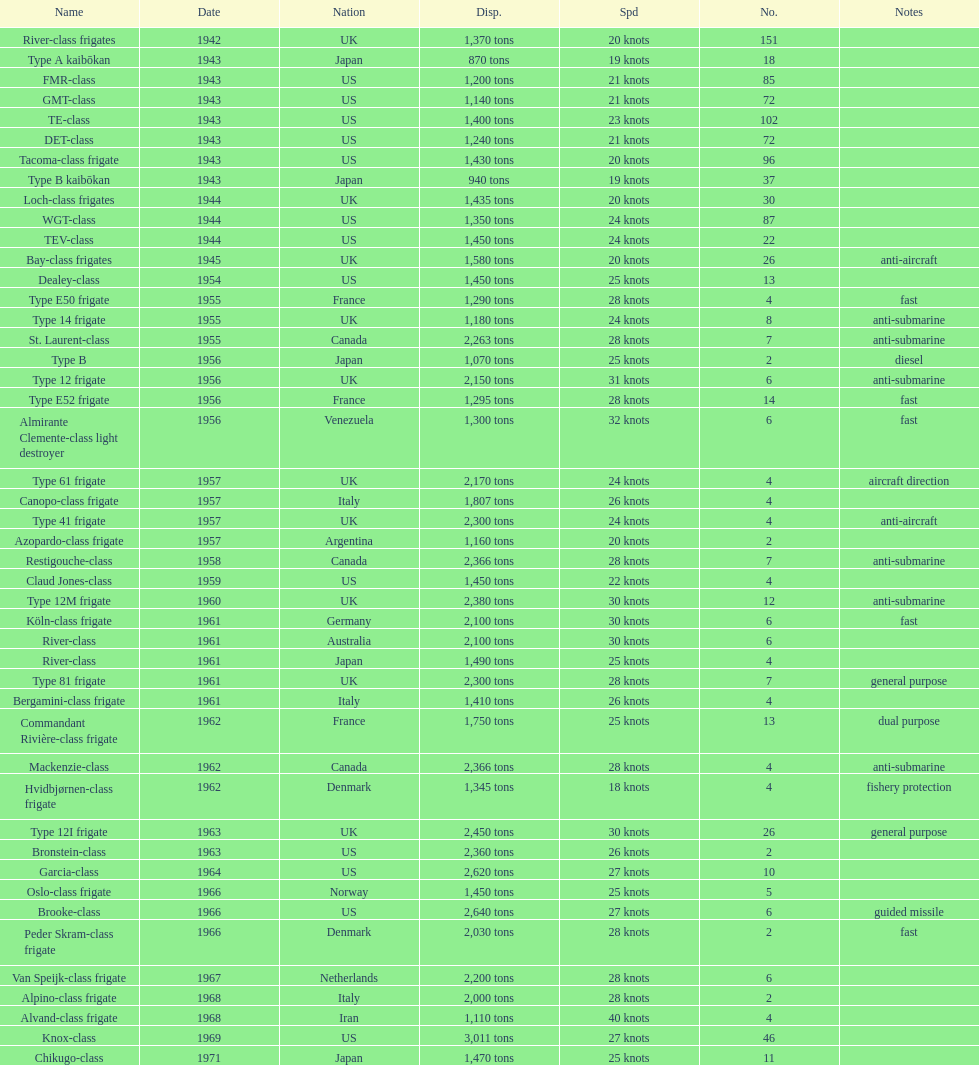What is the top speed? 40 knots. 